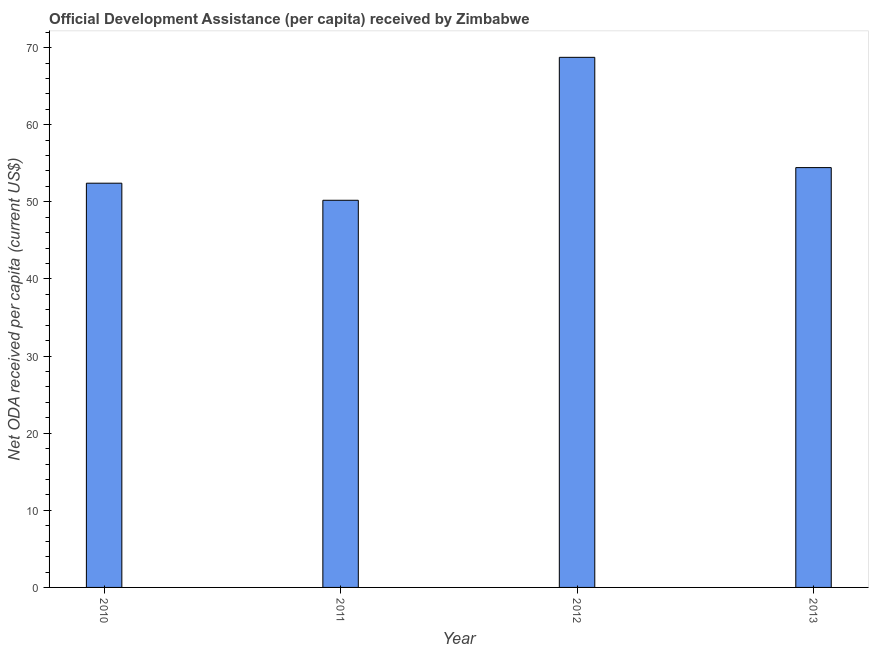Does the graph contain any zero values?
Provide a succinct answer. No. Does the graph contain grids?
Offer a very short reply. No. What is the title of the graph?
Your response must be concise. Official Development Assistance (per capita) received by Zimbabwe. What is the label or title of the X-axis?
Ensure brevity in your answer.  Year. What is the label or title of the Y-axis?
Make the answer very short. Net ODA received per capita (current US$). What is the net oda received per capita in 2012?
Ensure brevity in your answer.  68.74. Across all years, what is the maximum net oda received per capita?
Give a very brief answer. 68.74. Across all years, what is the minimum net oda received per capita?
Keep it short and to the point. 50.2. In which year was the net oda received per capita maximum?
Provide a short and direct response. 2012. In which year was the net oda received per capita minimum?
Keep it short and to the point. 2011. What is the sum of the net oda received per capita?
Keep it short and to the point. 225.8. What is the difference between the net oda received per capita in 2010 and 2011?
Offer a terse response. 2.21. What is the average net oda received per capita per year?
Your answer should be very brief. 56.45. What is the median net oda received per capita?
Offer a terse response. 53.43. What is the ratio of the net oda received per capita in 2010 to that in 2011?
Make the answer very short. 1.04. Is the difference between the net oda received per capita in 2011 and 2013 greater than the difference between any two years?
Keep it short and to the point. No. What is the difference between the highest and the second highest net oda received per capita?
Your response must be concise. 14.3. What is the difference between the highest and the lowest net oda received per capita?
Provide a short and direct response. 18.54. In how many years, is the net oda received per capita greater than the average net oda received per capita taken over all years?
Give a very brief answer. 1. How many bars are there?
Your answer should be compact. 4. How many years are there in the graph?
Provide a succinct answer. 4. What is the Net ODA received per capita (current US$) of 2010?
Provide a succinct answer. 52.42. What is the Net ODA received per capita (current US$) in 2011?
Provide a succinct answer. 50.2. What is the Net ODA received per capita (current US$) in 2012?
Make the answer very short. 68.74. What is the Net ODA received per capita (current US$) of 2013?
Your answer should be very brief. 54.44. What is the difference between the Net ODA received per capita (current US$) in 2010 and 2011?
Make the answer very short. 2.21. What is the difference between the Net ODA received per capita (current US$) in 2010 and 2012?
Offer a very short reply. -16.32. What is the difference between the Net ODA received per capita (current US$) in 2010 and 2013?
Keep it short and to the point. -2.02. What is the difference between the Net ODA received per capita (current US$) in 2011 and 2012?
Provide a succinct answer. -18.54. What is the difference between the Net ODA received per capita (current US$) in 2011 and 2013?
Make the answer very short. -4.24. What is the difference between the Net ODA received per capita (current US$) in 2012 and 2013?
Ensure brevity in your answer.  14.3. What is the ratio of the Net ODA received per capita (current US$) in 2010 to that in 2011?
Your answer should be very brief. 1.04. What is the ratio of the Net ODA received per capita (current US$) in 2010 to that in 2012?
Offer a very short reply. 0.76. What is the ratio of the Net ODA received per capita (current US$) in 2011 to that in 2012?
Your answer should be compact. 0.73. What is the ratio of the Net ODA received per capita (current US$) in 2011 to that in 2013?
Offer a very short reply. 0.92. What is the ratio of the Net ODA received per capita (current US$) in 2012 to that in 2013?
Ensure brevity in your answer.  1.26. 